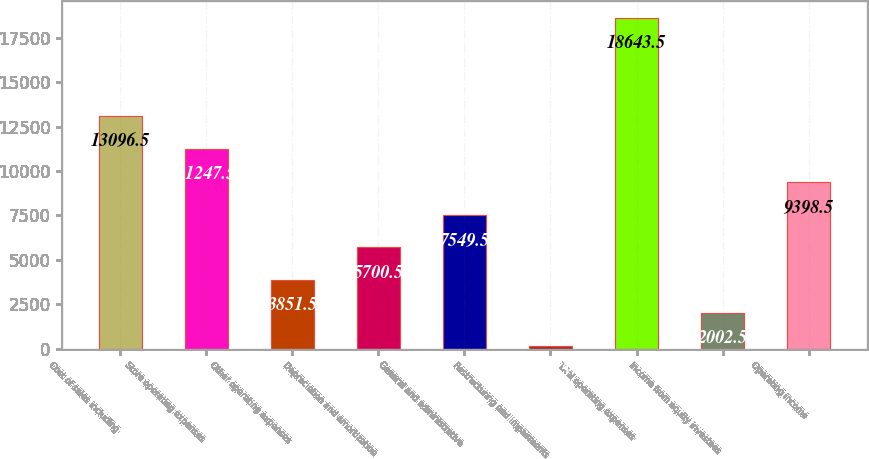Convert chart to OTSL. <chart><loc_0><loc_0><loc_500><loc_500><bar_chart><fcel>Cost of sales including<fcel>Store operating expenses<fcel>Other operating expenses<fcel>Depreciation and amortization<fcel>General and administrative<fcel>Restructuring and impairments<fcel>Total operating expenses<fcel>Income from equity investees<fcel>Operating income<nl><fcel>13096.5<fcel>11247.5<fcel>3851.5<fcel>5700.5<fcel>7549.5<fcel>153.5<fcel>18643.5<fcel>2002.5<fcel>9398.5<nl></chart> 